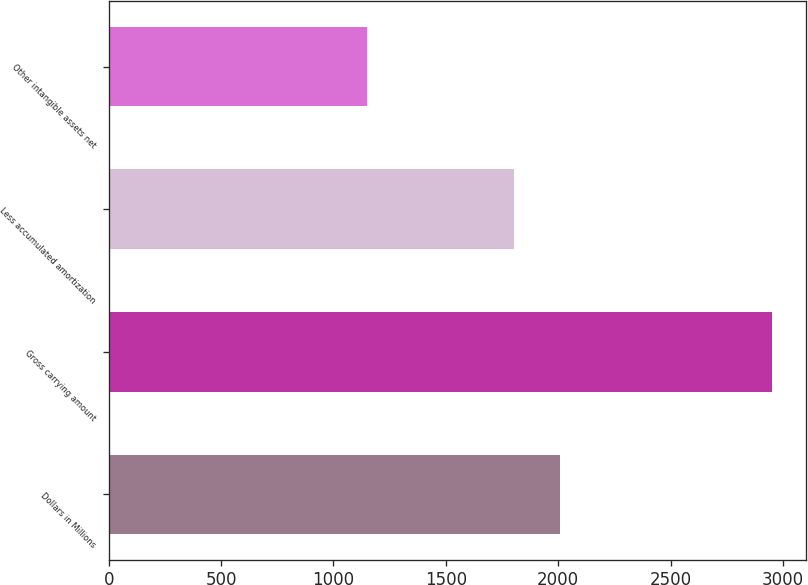Convert chart. <chart><loc_0><loc_0><loc_500><loc_500><bar_chart><fcel>Dollars in Millions<fcel>Gross carrying amount<fcel>Less accumulated amortization<fcel>Other intangible assets net<nl><fcel>2008<fcel>2953<fcel>1802<fcel>1151<nl></chart> 